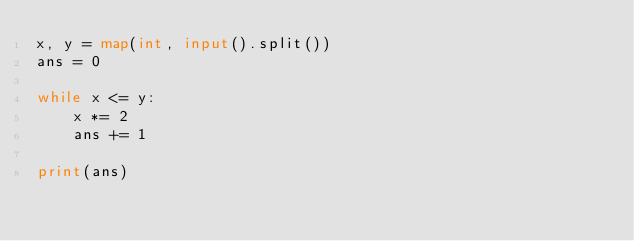Convert code to text. <code><loc_0><loc_0><loc_500><loc_500><_Python_>x, y = map(int, input().split())
ans = 0

while x <= y:
    x *= 2
    ans += 1

print(ans)
</code> 